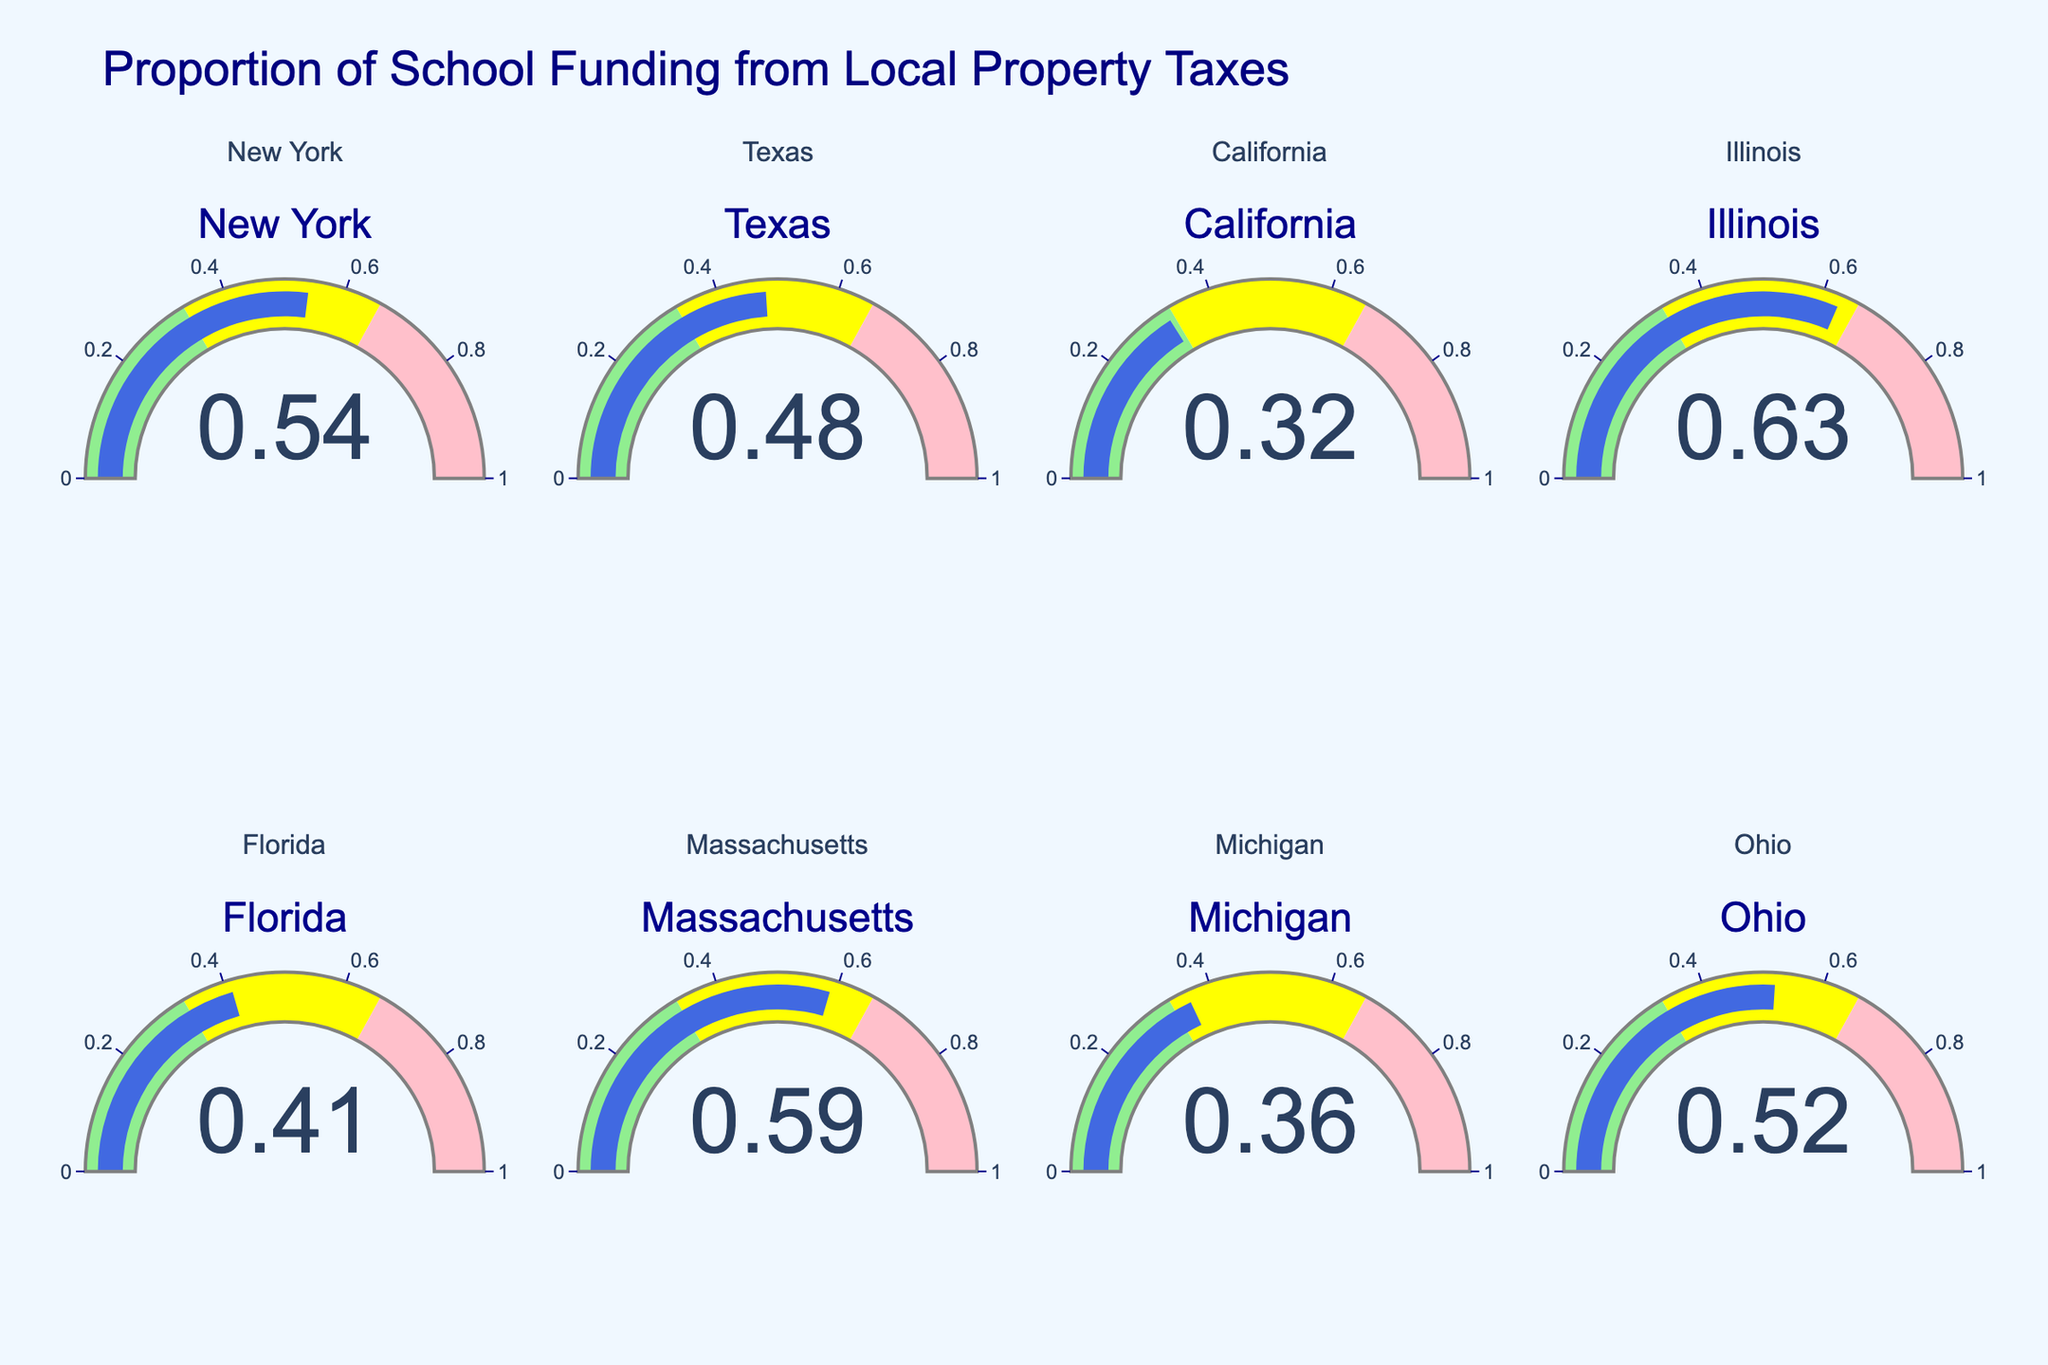What is the title of the figure? The title is at the top of the figure, displaying the main topic being visualized. The text "Proportion of School Funding from Local Property Taxes" is clearly visible.
Answer: Proportion of School Funding from Local Property Taxes Which state has the highest proportion of school funding from local property taxes? By looking at the gauge charts for each state, identify the one with the highest numerical value. Illinois is at 0.63, which is higher than all the others.
Answer: Illinois What is the lowest proportion of school funding from local property taxes among the states? Find and compare all the values displayed in the gauge charts. California has the lowest value at 0.32.
Answer: California How many states have their school funding proportion from local property taxes above 0.50? Count the states where the value displayed on the gauge chart is greater than 0.50. New York, Illinois, Massachusetts, and Ohio qualify.
Answer: 4 Which states have a school funding proportion between 0.40 and 0.50? Check the gauge charts for states that have values within the specified range. Texas and Florida fall within this range.
Answer: Texas, Florida What is the average proportion of school funding from local property taxes across all states depicted? Add all the values from the gauge charts and divide by the number of states: (0.54 + 0.48 + 0.32 + 0.63 + 0.41 + 0.59 + 0.36 + 0.52) / 8 = 3.85 / 8 = 0.48125
Answer: 0.48125 Compare the proportion of school funding from local property taxes between New York and California. Which one is lower? Look at the gauge charts for New York and California, compare the values: New York is 0.54 and California is 0.32. California is lower.
Answer: California What color represents the range for the lowest proportion of funding (0 to 0.33) on the gauge charts? Observe the sections on the gauge charts. The segment from 0 to 0.33 is colored in light green.
Answer: Light green Which state falls into the middle range (0.33 to 0.66) for the proportion of school funding from local property taxes? Identify states with values in the middle range, indicated by yellow. New York, Texas, Florida, Massachusetts, Michigan, and Ohio are within this range.
Answer: New York, Texas, Florida, Massachusetts, Michigan, Ohio 